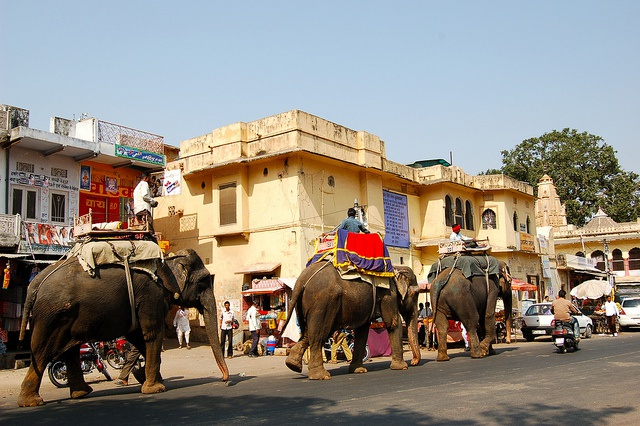Describe the objects in this image and their specific colors. I can see elephant in lightblue, black, maroon, and gray tones, elephant in lightblue, black, maroon, and olive tones, elephant in lightblue, black, maroon, and brown tones, car in lightblue, black, white, darkgray, and gray tones, and motorcycle in lightblue, black, gray, and maroon tones in this image. 